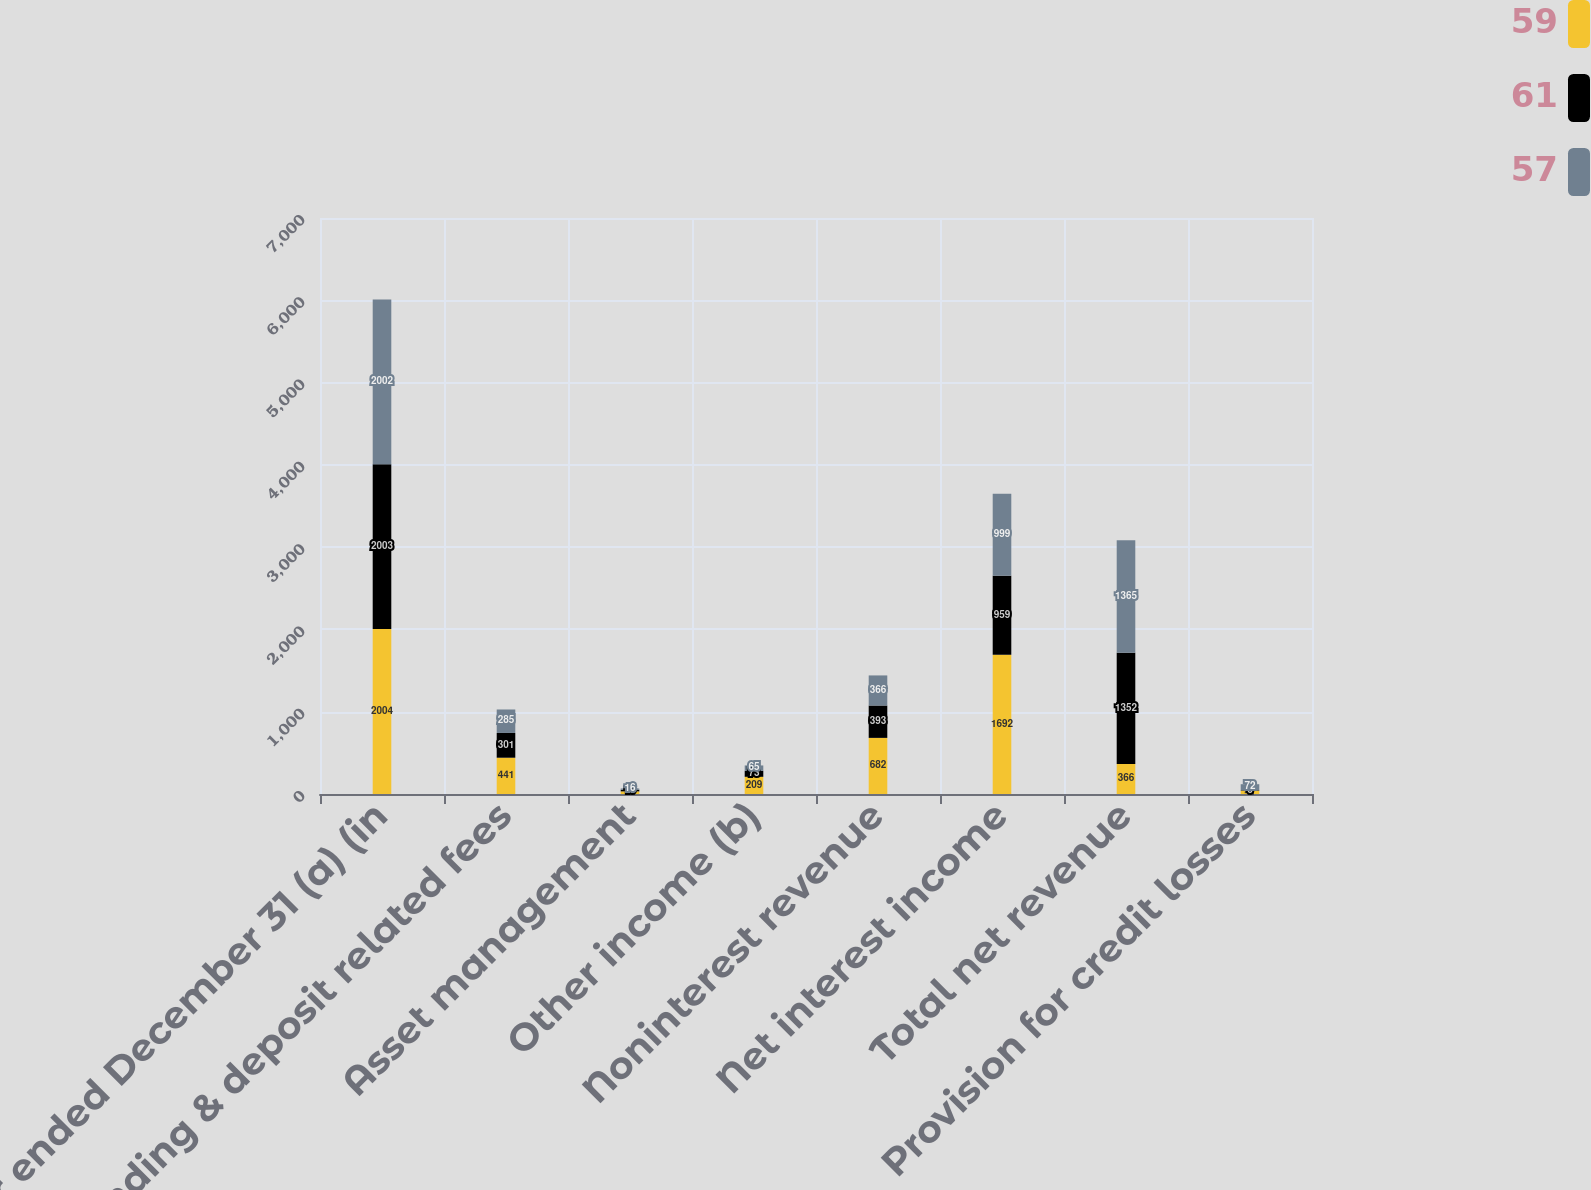<chart> <loc_0><loc_0><loc_500><loc_500><stacked_bar_chart><ecel><fcel>Year ended December 31 (a) (in<fcel>Lending & deposit related fees<fcel>Asset management<fcel>Other income (b)<fcel>Noninterest revenue<fcel>Net interest income<fcel>Total net revenue<fcel>Provision for credit losses<nl><fcel>59<fcel>2004<fcel>441<fcel>32<fcel>209<fcel>682<fcel>1692<fcel>366<fcel>41<nl><fcel>61<fcel>2003<fcel>301<fcel>19<fcel>73<fcel>393<fcel>959<fcel>1352<fcel>6<nl><fcel>57<fcel>2002<fcel>285<fcel>16<fcel>65<fcel>366<fcel>999<fcel>1365<fcel>72<nl></chart> 